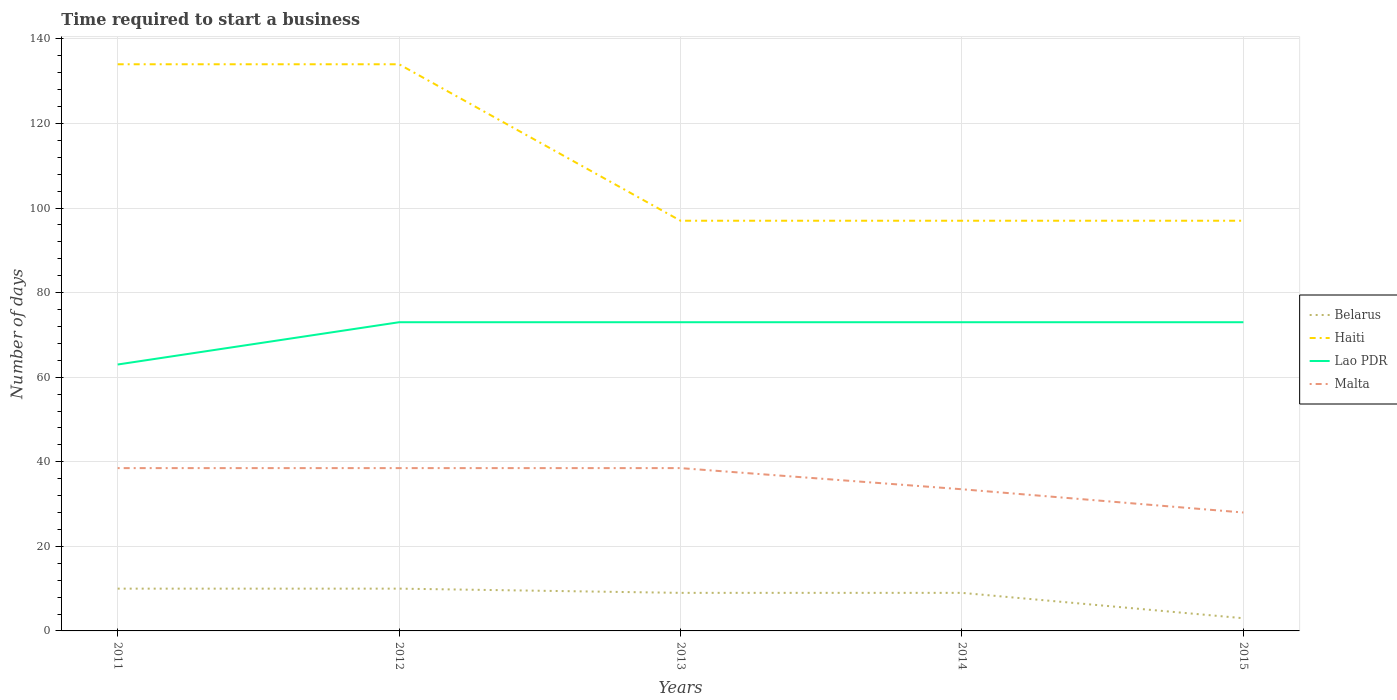How many different coloured lines are there?
Provide a succinct answer. 4. Across all years, what is the maximum number of days required to start a business in Lao PDR?
Your answer should be compact. 63. In which year was the number of days required to start a business in Belarus maximum?
Give a very brief answer. 2015. What is the difference between the highest and the second highest number of days required to start a business in Haiti?
Your answer should be compact. 37. How many lines are there?
Provide a short and direct response. 4. How many years are there in the graph?
Give a very brief answer. 5. What is the difference between two consecutive major ticks on the Y-axis?
Make the answer very short. 20. Does the graph contain grids?
Your answer should be very brief. Yes. How many legend labels are there?
Give a very brief answer. 4. What is the title of the graph?
Give a very brief answer. Time required to start a business. Does "Yemen, Rep." appear as one of the legend labels in the graph?
Your answer should be very brief. No. What is the label or title of the Y-axis?
Make the answer very short. Number of days. What is the Number of days in Belarus in 2011?
Make the answer very short. 10. What is the Number of days of Haiti in 2011?
Your answer should be compact. 134. What is the Number of days of Lao PDR in 2011?
Keep it short and to the point. 63. What is the Number of days in Malta in 2011?
Provide a short and direct response. 38.5. What is the Number of days of Haiti in 2012?
Make the answer very short. 134. What is the Number of days in Lao PDR in 2012?
Provide a short and direct response. 73. What is the Number of days in Malta in 2012?
Provide a succinct answer. 38.5. What is the Number of days in Haiti in 2013?
Ensure brevity in your answer.  97. What is the Number of days of Malta in 2013?
Your answer should be compact. 38.5. What is the Number of days in Belarus in 2014?
Your response must be concise. 9. What is the Number of days of Haiti in 2014?
Keep it short and to the point. 97. What is the Number of days of Lao PDR in 2014?
Your answer should be compact. 73. What is the Number of days in Malta in 2014?
Make the answer very short. 33.5. What is the Number of days of Belarus in 2015?
Keep it short and to the point. 3. What is the Number of days in Haiti in 2015?
Provide a succinct answer. 97. What is the Number of days in Lao PDR in 2015?
Ensure brevity in your answer.  73. What is the Number of days of Malta in 2015?
Provide a short and direct response. 28. Across all years, what is the maximum Number of days in Haiti?
Offer a very short reply. 134. Across all years, what is the maximum Number of days of Malta?
Offer a very short reply. 38.5. Across all years, what is the minimum Number of days of Belarus?
Offer a terse response. 3. Across all years, what is the minimum Number of days of Haiti?
Provide a short and direct response. 97. Across all years, what is the minimum Number of days of Lao PDR?
Your answer should be compact. 63. Across all years, what is the minimum Number of days in Malta?
Keep it short and to the point. 28. What is the total Number of days in Haiti in the graph?
Ensure brevity in your answer.  559. What is the total Number of days of Lao PDR in the graph?
Provide a succinct answer. 355. What is the total Number of days of Malta in the graph?
Provide a succinct answer. 177. What is the difference between the Number of days of Belarus in 2011 and that in 2013?
Keep it short and to the point. 1. What is the difference between the Number of days of Malta in 2011 and that in 2013?
Provide a succinct answer. 0. What is the difference between the Number of days of Haiti in 2011 and that in 2014?
Ensure brevity in your answer.  37. What is the difference between the Number of days of Lao PDR in 2011 and that in 2014?
Provide a succinct answer. -10. What is the difference between the Number of days in Malta in 2011 and that in 2014?
Make the answer very short. 5. What is the difference between the Number of days in Malta in 2011 and that in 2015?
Give a very brief answer. 10.5. What is the difference between the Number of days of Lao PDR in 2012 and that in 2014?
Your response must be concise. 0. What is the difference between the Number of days of Malta in 2012 and that in 2014?
Give a very brief answer. 5. What is the difference between the Number of days of Haiti in 2012 and that in 2015?
Make the answer very short. 37. What is the difference between the Number of days in Lao PDR in 2012 and that in 2015?
Provide a succinct answer. 0. What is the difference between the Number of days of Malta in 2012 and that in 2015?
Provide a succinct answer. 10.5. What is the difference between the Number of days in Belarus in 2013 and that in 2014?
Give a very brief answer. 0. What is the difference between the Number of days in Lao PDR in 2013 and that in 2014?
Make the answer very short. 0. What is the difference between the Number of days in Malta in 2013 and that in 2015?
Your answer should be very brief. 10.5. What is the difference between the Number of days in Haiti in 2014 and that in 2015?
Your answer should be compact. 0. What is the difference between the Number of days of Lao PDR in 2014 and that in 2015?
Ensure brevity in your answer.  0. What is the difference between the Number of days in Belarus in 2011 and the Number of days in Haiti in 2012?
Keep it short and to the point. -124. What is the difference between the Number of days in Belarus in 2011 and the Number of days in Lao PDR in 2012?
Your answer should be compact. -63. What is the difference between the Number of days in Belarus in 2011 and the Number of days in Malta in 2012?
Your answer should be very brief. -28.5. What is the difference between the Number of days of Haiti in 2011 and the Number of days of Lao PDR in 2012?
Keep it short and to the point. 61. What is the difference between the Number of days in Haiti in 2011 and the Number of days in Malta in 2012?
Give a very brief answer. 95.5. What is the difference between the Number of days in Lao PDR in 2011 and the Number of days in Malta in 2012?
Your answer should be compact. 24.5. What is the difference between the Number of days of Belarus in 2011 and the Number of days of Haiti in 2013?
Provide a succinct answer. -87. What is the difference between the Number of days in Belarus in 2011 and the Number of days in Lao PDR in 2013?
Offer a terse response. -63. What is the difference between the Number of days in Belarus in 2011 and the Number of days in Malta in 2013?
Make the answer very short. -28.5. What is the difference between the Number of days of Haiti in 2011 and the Number of days of Malta in 2013?
Your answer should be very brief. 95.5. What is the difference between the Number of days in Belarus in 2011 and the Number of days in Haiti in 2014?
Provide a succinct answer. -87. What is the difference between the Number of days of Belarus in 2011 and the Number of days of Lao PDR in 2014?
Your answer should be compact. -63. What is the difference between the Number of days of Belarus in 2011 and the Number of days of Malta in 2014?
Your answer should be compact. -23.5. What is the difference between the Number of days in Haiti in 2011 and the Number of days in Lao PDR in 2014?
Make the answer very short. 61. What is the difference between the Number of days of Haiti in 2011 and the Number of days of Malta in 2014?
Your answer should be very brief. 100.5. What is the difference between the Number of days in Lao PDR in 2011 and the Number of days in Malta in 2014?
Your answer should be compact. 29.5. What is the difference between the Number of days in Belarus in 2011 and the Number of days in Haiti in 2015?
Provide a short and direct response. -87. What is the difference between the Number of days in Belarus in 2011 and the Number of days in Lao PDR in 2015?
Your answer should be compact. -63. What is the difference between the Number of days of Belarus in 2011 and the Number of days of Malta in 2015?
Your answer should be compact. -18. What is the difference between the Number of days in Haiti in 2011 and the Number of days in Malta in 2015?
Give a very brief answer. 106. What is the difference between the Number of days in Lao PDR in 2011 and the Number of days in Malta in 2015?
Make the answer very short. 35. What is the difference between the Number of days in Belarus in 2012 and the Number of days in Haiti in 2013?
Provide a succinct answer. -87. What is the difference between the Number of days in Belarus in 2012 and the Number of days in Lao PDR in 2013?
Your response must be concise. -63. What is the difference between the Number of days of Belarus in 2012 and the Number of days of Malta in 2013?
Ensure brevity in your answer.  -28.5. What is the difference between the Number of days in Haiti in 2012 and the Number of days in Malta in 2013?
Make the answer very short. 95.5. What is the difference between the Number of days in Lao PDR in 2012 and the Number of days in Malta in 2013?
Keep it short and to the point. 34.5. What is the difference between the Number of days of Belarus in 2012 and the Number of days of Haiti in 2014?
Ensure brevity in your answer.  -87. What is the difference between the Number of days in Belarus in 2012 and the Number of days in Lao PDR in 2014?
Offer a terse response. -63. What is the difference between the Number of days in Belarus in 2012 and the Number of days in Malta in 2014?
Make the answer very short. -23.5. What is the difference between the Number of days in Haiti in 2012 and the Number of days in Malta in 2014?
Provide a short and direct response. 100.5. What is the difference between the Number of days in Lao PDR in 2012 and the Number of days in Malta in 2014?
Your answer should be very brief. 39.5. What is the difference between the Number of days in Belarus in 2012 and the Number of days in Haiti in 2015?
Keep it short and to the point. -87. What is the difference between the Number of days of Belarus in 2012 and the Number of days of Lao PDR in 2015?
Keep it short and to the point. -63. What is the difference between the Number of days in Haiti in 2012 and the Number of days in Lao PDR in 2015?
Your answer should be very brief. 61. What is the difference between the Number of days of Haiti in 2012 and the Number of days of Malta in 2015?
Give a very brief answer. 106. What is the difference between the Number of days in Belarus in 2013 and the Number of days in Haiti in 2014?
Offer a terse response. -88. What is the difference between the Number of days of Belarus in 2013 and the Number of days of Lao PDR in 2014?
Offer a terse response. -64. What is the difference between the Number of days in Belarus in 2013 and the Number of days in Malta in 2014?
Offer a very short reply. -24.5. What is the difference between the Number of days in Haiti in 2013 and the Number of days in Malta in 2014?
Your answer should be compact. 63.5. What is the difference between the Number of days in Lao PDR in 2013 and the Number of days in Malta in 2014?
Your answer should be compact. 39.5. What is the difference between the Number of days in Belarus in 2013 and the Number of days in Haiti in 2015?
Make the answer very short. -88. What is the difference between the Number of days of Belarus in 2013 and the Number of days of Lao PDR in 2015?
Provide a short and direct response. -64. What is the difference between the Number of days of Haiti in 2013 and the Number of days of Lao PDR in 2015?
Offer a very short reply. 24. What is the difference between the Number of days of Haiti in 2013 and the Number of days of Malta in 2015?
Your answer should be compact. 69. What is the difference between the Number of days of Belarus in 2014 and the Number of days of Haiti in 2015?
Provide a short and direct response. -88. What is the difference between the Number of days of Belarus in 2014 and the Number of days of Lao PDR in 2015?
Make the answer very short. -64. What is the difference between the Number of days of Haiti in 2014 and the Number of days of Lao PDR in 2015?
Your answer should be very brief. 24. What is the difference between the Number of days in Lao PDR in 2014 and the Number of days in Malta in 2015?
Provide a succinct answer. 45. What is the average Number of days in Belarus per year?
Your answer should be very brief. 8.2. What is the average Number of days of Haiti per year?
Make the answer very short. 111.8. What is the average Number of days in Malta per year?
Provide a succinct answer. 35.4. In the year 2011, what is the difference between the Number of days of Belarus and Number of days of Haiti?
Offer a very short reply. -124. In the year 2011, what is the difference between the Number of days in Belarus and Number of days in Lao PDR?
Your answer should be compact. -53. In the year 2011, what is the difference between the Number of days of Belarus and Number of days of Malta?
Give a very brief answer. -28.5. In the year 2011, what is the difference between the Number of days in Haiti and Number of days in Malta?
Ensure brevity in your answer.  95.5. In the year 2011, what is the difference between the Number of days of Lao PDR and Number of days of Malta?
Offer a terse response. 24.5. In the year 2012, what is the difference between the Number of days in Belarus and Number of days in Haiti?
Your response must be concise. -124. In the year 2012, what is the difference between the Number of days in Belarus and Number of days in Lao PDR?
Your response must be concise. -63. In the year 2012, what is the difference between the Number of days of Belarus and Number of days of Malta?
Offer a very short reply. -28.5. In the year 2012, what is the difference between the Number of days of Haiti and Number of days of Malta?
Offer a terse response. 95.5. In the year 2012, what is the difference between the Number of days in Lao PDR and Number of days in Malta?
Keep it short and to the point. 34.5. In the year 2013, what is the difference between the Number of days in Belarus and Number of days in Haiti?
Your response must be concise. -88. In the year 2013, what is the difference between the Number of days of Belarus and Number of days of Lao PDR?
Your answer should be very brief. -64. In the year 2013, what is the difference between the Number of days in Belarus and Number of days in Malta?
Your answer should be compact. -29.5. In the year 2013, what is the difference between the Number of days of Haiti and Number of days of Malta?
Offer a very short reply. 58.5. In the year 2013, what is the difference between the Number of days of Lao PDR and Number of days of Malta?
Keep it short and to the point. 34.5. In the year 2014, what is the difference between the Number of days of Belarus and Number of days of Haiti?
Your response must be concise. -88. In the year 2014, what is the difference between the Number of days of Belarus and Number of days of Lao PDR?
Make the answer very short. -64. In the year 2014, what is the difference between the Number of days in Belarus and Number of days in Malta?
Make the answer very short. -24.5. In the year 2014, what is the difference between the Number of days of Haiti and Number of days of Malta?
Your answer should be compact. 63.5. In the year 2014, what is the difference between the Number of days in Lao PDR and Number of days in Malta?
Make the answer very short. 39.5. In the year 2015, what is the difference between the Number of days in Belarus and Number of days in Haiti?
Keep it short and to the point. -94. In the year 2015, what is the difference between the Number of days of Belarus and Number of days of Lao PDR?
Your answer should be very brief. -70. In the year 2015, what is the difference between the Number of days of Belarus and Number of days of Malta?
Keep it short and to the point. -25. In the year 2015, what is the difference between the Number of days in Lao PDR and Number of days in Malta?
Make the answer very short. 45. What is the ratio of the Number of days of Haiti in 2011 to that in 2012?
Your answer should be very brief. 1. What is the ratio of the Number of days in Lao PDR in 2011 to that in 2012?
Ensure brevity in your answer.  0.86. What is the ratio of the Number of days of Malta in 2011 to that in 2012?
Provide a short and direct response. 1. What is the ratio of the Number of days of Haiti in 2011 to that in 2013?
Give a very brief answer. 1.38. What is the ratio of the Number of days in Lao PDR in 2011 to that in 2013?
Keep it short and to the point. 0.86. What is the ratio of the Number of days of Haiti in 2011 to that in 2014?
Keep it short and to the point. 1.38. What is the ratio of the Number of days in Lao PDR in 2011 to that in 2014?
Give a very brief answer. 0.86. What is the ratio of the Number of days in Malta in 2011 to that in 2014?
Ensure brevity in your answer.  1.15. What is the ratio of the Number of days of Haiti in 2011 to that in 2015?
Your response must be concise. 1.38. What is the ratio of the Number of days in Lao PDR in 2011 to that in 2015?
Your answer should be very brief. 0.86. What is the ratio of the Number of days in Malta in 2011 to that in 2015?
Offer a very short reply. 1.38. What is the ratio of the Number of days of Haiti in 2012 to that in 2013?
Your answer should be compact. 1.38. What is the ratio of the Number of days in Belarus in 2012 to that in 2014?
Provide a succinct answer. 1.11. What is the ratio of the Number of days in Haiti in 2012 to that in 2014?
Keep it short and to the point. 1.38. What is the ratio of the Number of days of Malta in 2012 to that in 2014?
Give a very brief answer. 1.15. What is the ratio of the Number of days in Haiti in 2012 to that in 2015?
Your response must be concise. 1.38. What is the ratio of the Number of days of Malta in 2012 to that in 2015?
Make the answer very short. 1.38. What is the ratio of the Number of days in Belarus in 2013 to that in 2014?
Your answer should be very brief. 1. What is the ratio of the Number of days in Lao PDR in 2013 to that in 2014?
Make the answer very short. 1. What is the ratio of the Number of days of Malta in 2013 to that in 2014?
Your answer should be compact. 1.15. What is the ratio of the Number of days of Belarus in 2013 to that in 2015?
Give a very brief answer. 3. What is the ratio of the Number of days in Malta in 2013 to that in 2015?
Provide a succinct answer. 1.38. What is the ratio of the Number of days of Belarus in 2014 to that in 2015?
Ensure brevity in your answer.  3. What is the ratio of the Number of days of Haiti in 2014 to that in 2015?
Keep it short and to the point. 1. What is the ratio of the Number of days of Lao PDR in 2014 to that in 2015?
Make the answer very short. 1. What is the ratio of the Number of days of Malta in 2014 to that in 2015?
Offer a very short reply. 1.2. What is the difference between the highest and the second highest Number of days of Lao PDR?
Give a very brief answer. 0. What is the difference between the highest and the second highest Number of days in Malta?
Your answer should be compact. 0. What is the difference between the highest and the lowest Number of days in Belarus?
Ensure brevity in your answer.  7. What is the difference between the highest and the lowest Number of days of Lao PDR?
Provide a succinct answer. 10. 